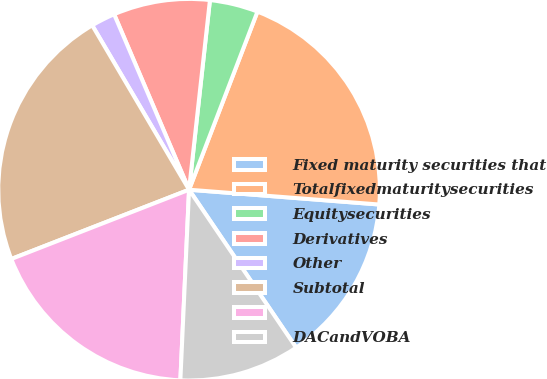<chart> <loc_0><loc_0><loc_500><loc_500><pie_chart><fcel>Fixed maturity securities that<fcel>Totalfixedmaturitysecurities<fcel>Equitysecurities<fcel>Derivatives<fcel>Other<fcel>Subtotal<fcel>Unnamed: 6<fcel>DACandVOBA<nl><fcel>14.28%<fcel>20.4%<fcel>4.09%<fcel>8.17%<fcel>2.05%<fcel>22.44%<fcel>18.36%<fcel>10.21%<nl></chart> 